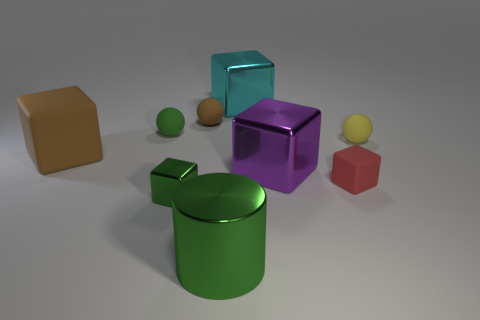Subtract 2 blocks. How many blocks are left? 3 Subtract all brown cubes. How many cubes are left? 4 Subtract all green shiny cubes. How many cubes are left? 4 Subtract all gray blocks. Subtract all blue balls. How many blocks are left? 5 Add 1 large green metal spheres. How many objects exist? 10 Subtract all cylinders. How many objects are left? 8 Add 7 yellow balls. How many yellow balls are left? 8 Add 6 large brown matte cubes. How many large brown matte cubes exist? 7 Subtract 1 cyan cubes. How many objects are left? 8 Subtract all red cubes. Subtract all tiny red cubes. How many objects are left? 7 